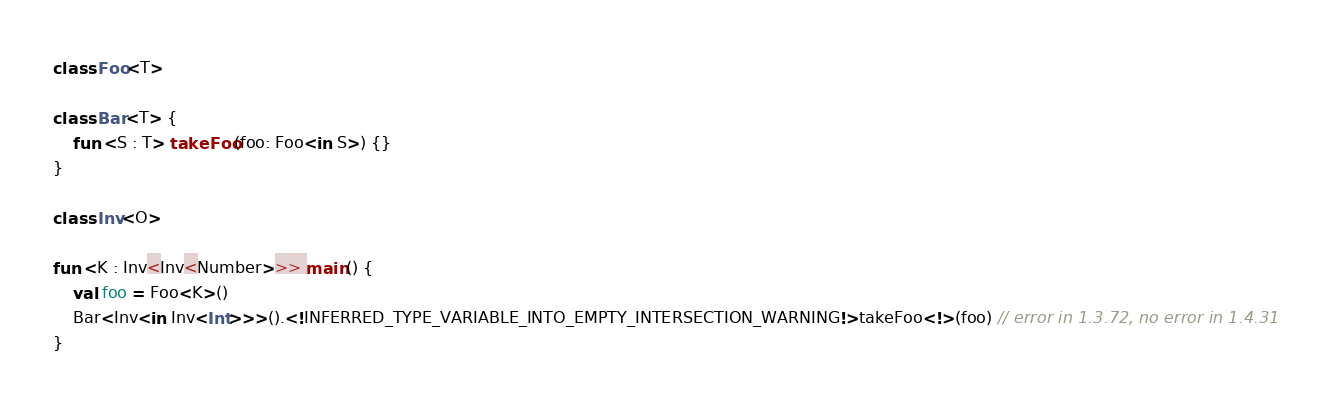<code> <loc_0><loc_0><loc_500><loc_500><_Kotlin_>class Foo<T>

class Bar<T> {
    fun <S : T> takeFoo(foo: Foo<in S>) {}
}

class Inv<O>

fun <K : Inv<Inv<Number>>> main() {
    val foo = Foo<K>()
    Bar<Inv<in Inv<Int>>>().<!INFERRED_TYPE_VARIABLE_INTO_EMPTY_INTERSECTION_WARNING!>takeFoo<!>(foo) // error in 1.3.72, no error in 1.4.31
}
</code> 